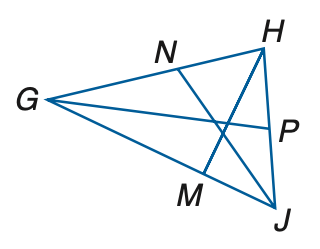Answer the mathemtical geometry problem and directly provide the correct option letter.
Question: In \triangle G H J, H P = 5 x - 16, P J = 3 x + 8, m \angle G J N = 6 y - 3, m \angle N J H = 4 y + 23 and m \angle H M G = 4 z + 14. If H M is an altitude of \angle G H J, find the value of z.
Choices: A: 16 B: 17 C: 18 D: 19 D 